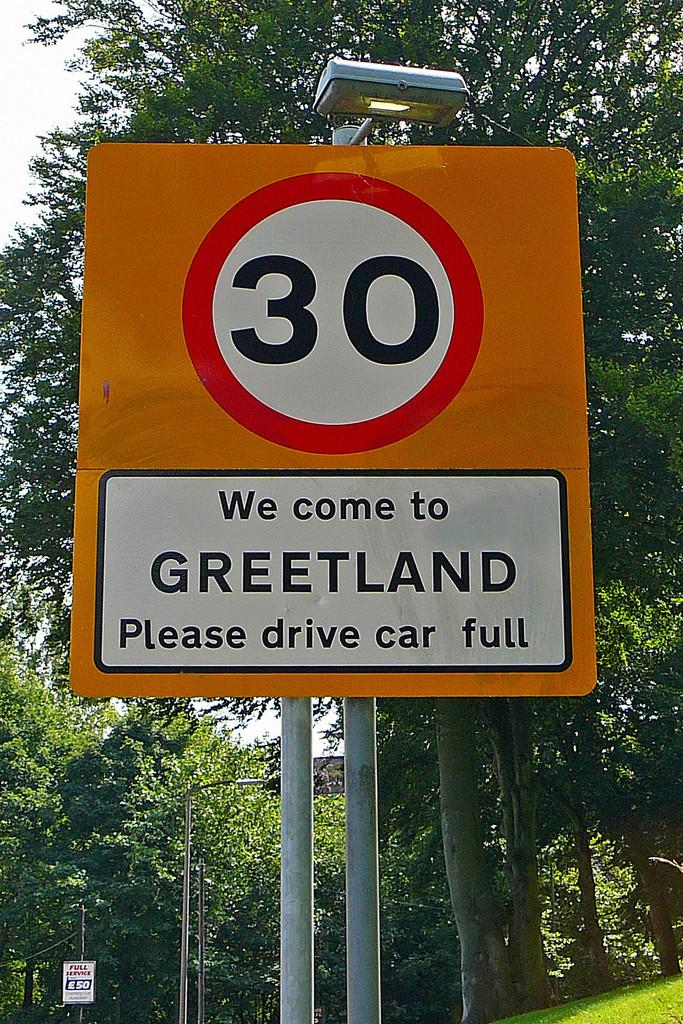<image>
Write a terse but informative summary of the picture. Sign on a street which says "We come to Greetland" on it. 